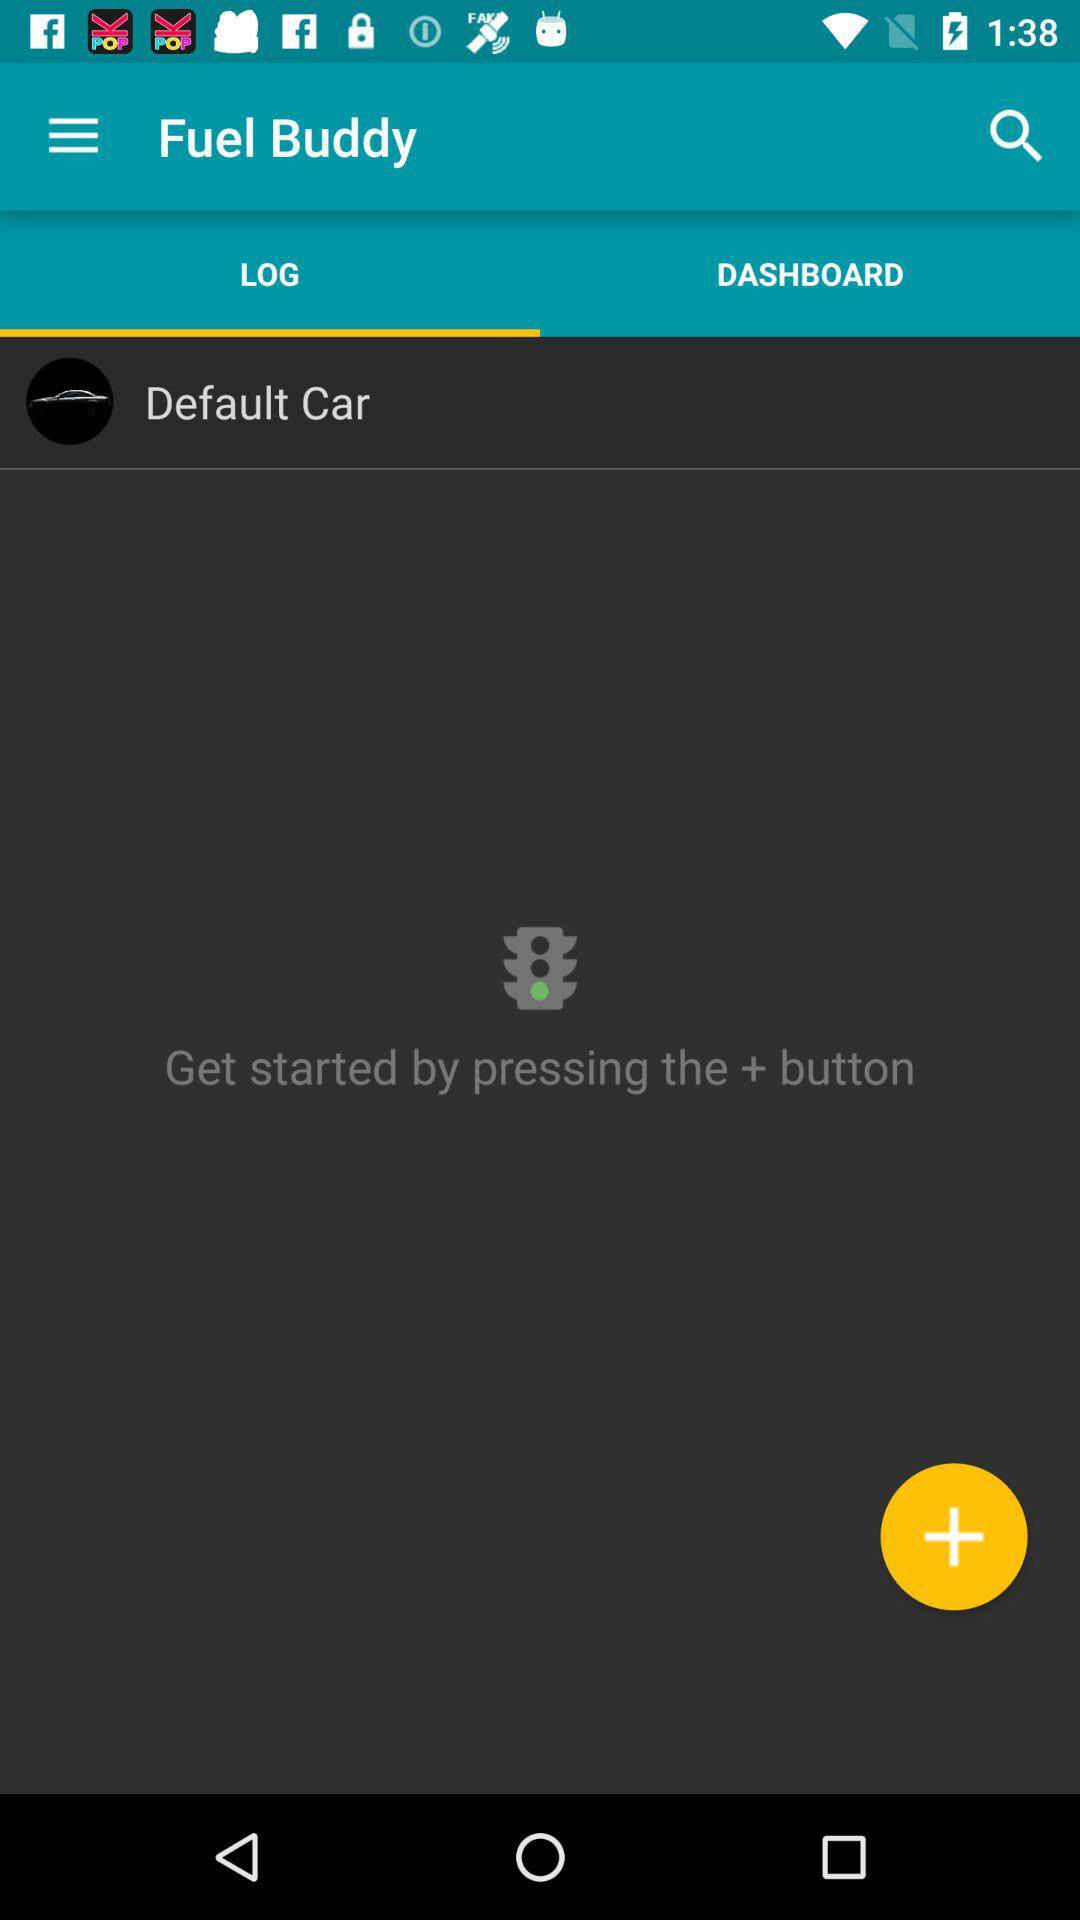Which tab is selected? The selected tab is "LOG". 